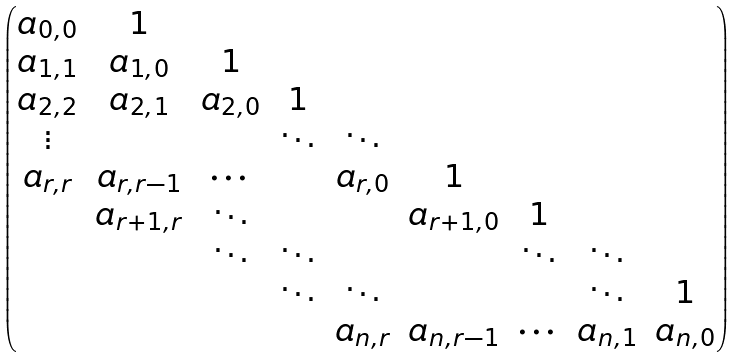<formula> <loc_0><loc_0><loc_500><loc_500>\begin{pmatrix} a _ { 0 , 0 } & 1 & \\ a _ { 1 , 1 } & a _ { 1 , 0 } & 1 \\ a _ { 2 , 2 } & a _ { 2 , 1 } & a _ { 2 , 0 } & 1 \\ \vdots & & & \ddots & \ddots \\ a _ { r , r } & a _ { r , r - 1 } & \cdots & & a _ { r , 0 } & 1 \\ & a _ { r + 1 , r } & \ddots & & & a _ { r + 1 , 0 } & 1 \\ & & \ddots & \ddots & & & \ddots & \ddots \\ & & & \ddots & \ddots & & & \ddots & 1 \\ & & & & a _ { n , r } & a _ { n , r - 1 } & \cdots & a _ { n , 1 } & a _ { n , 0 } \end{pmatrix}</formula> 